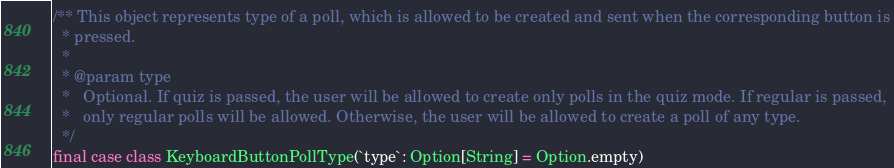<code> <loc_0><loc_0><loc_500><loc_500><_Scala_>/** This object represents type of a poll, which is allowed to be created and sent when the corresponding button is
  * pressed.
  *
  * @param type
  *   Optional. If quiz is passed, the user will be allowed to create only polls in the quiz mode. If regular is passed,
  *   only regular polls will be allowed. Otherwise, the user will be allowed to create a poll of any type.
  */
final case class KeyboardButtonPollType(`type`: Option[String] = Option.empty)
</code> 